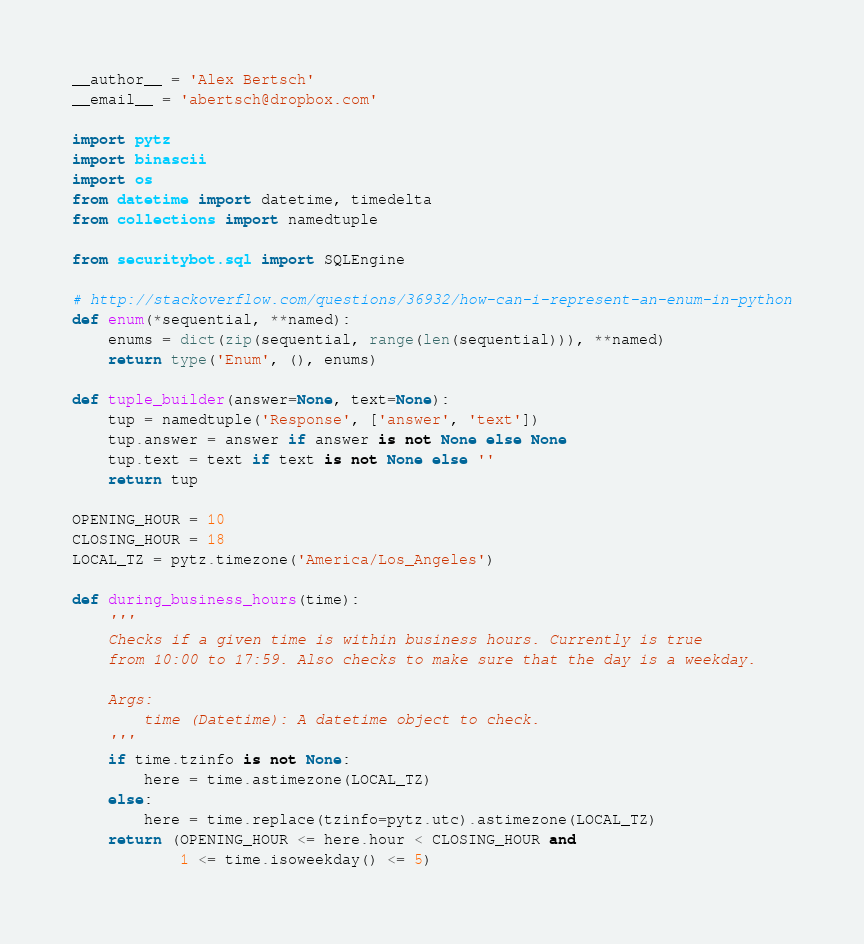<code> <loc_0><loc_0><loc_500><loc_500><_Python_>__author__ = 'Alex Bertsch'
__email__ = 'abertsch@dropbox.com'

import pytz
import binascii
import os
from datetime import datetime, timedelta
from collections import namedtuple

from securitybot.sql import SQLEngine

# http://stackoverflow.com/questions/36932/how-can-i-represent-an-enum-in-python
def enum(*sequential, **named):
    enums = dict(zip(sequential, range(len(sequential))), **named)
    return type('Enum', (), enums)

def tuple_builder(answer=None, text=None):
    tup = namedtuple('Response', ['answer', 'text'])
    tup.answer = answer if answer is not None else None
    tup.text = text if text is not None else ''
    return tup

OPENING_HOUR = 10
CLOSING_HOUR = 18
LOCAL_TZ = pytz.timezone('America/Los_Angeles')

def during_business_hours(time):
    '''
    Checks if a given time is within business hours. Currently is true
    from 10:00 to 17:59. Also checks to make sure that the day is a weekday.

    Args:
        time (Datetime): A datetime object to check.
    '''
    if time.tzinfo is not None:
        here = time.astimezone(LOCAL_TZ)
    else:
        here = time.replace(tzinfo=pytz.utc).astimezone(LOCAL_TZ)
    return (OPENING_HOUR <= here.hour < CLOSING_HOUR and
            1 <= time.isoweekday() <= 5)
</code> 